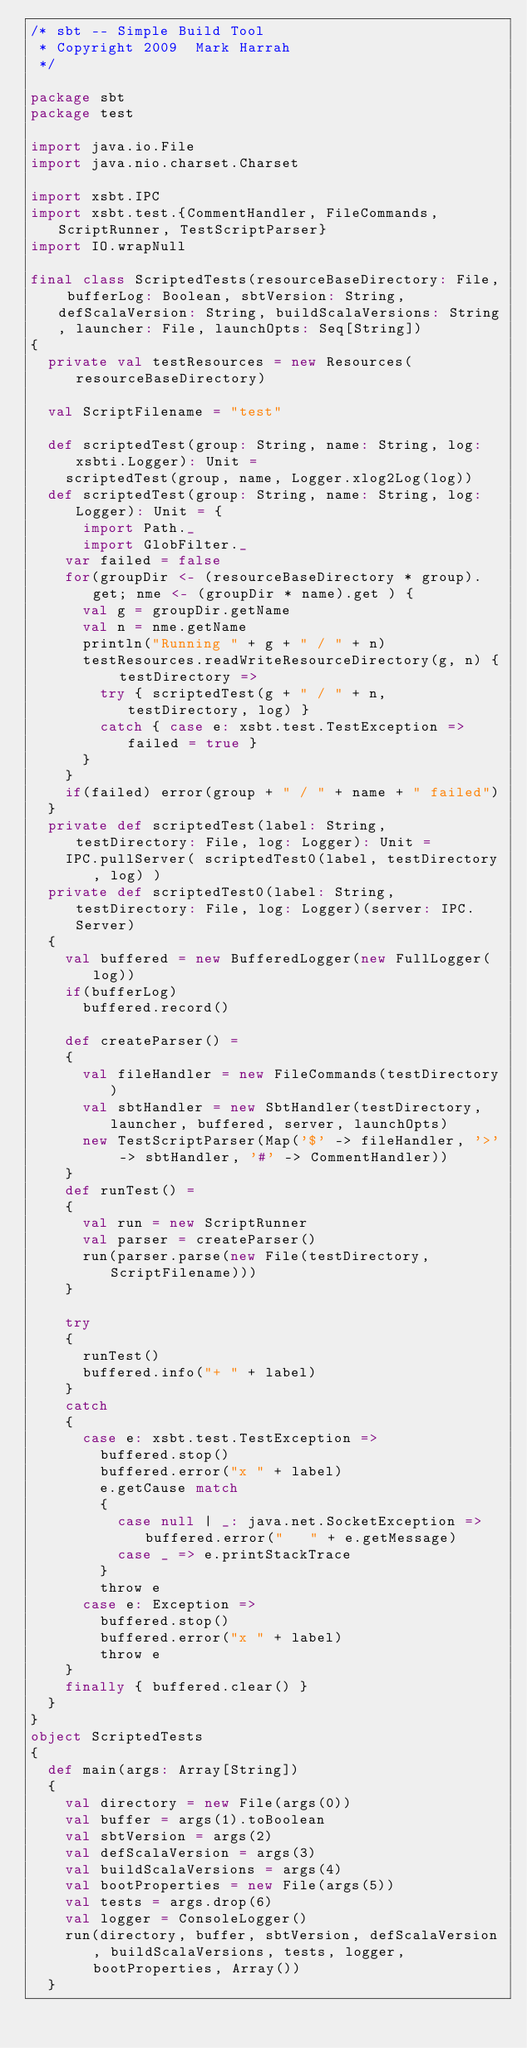Convert code to text. <code><loc_0><loc_0><loc_500><loc_500><_Scala_>/* sbt -- Simple Build Tool
 * Copyright 2009  Mark Harrah
 */

package sbt
package test

import java.io.File
import java.nio.charset.Charset

import xsbt.IPC
import xsbt.test.{CommentHandler, FileCommands, ScriptRunner, TestScriptParser}
import IO.wrapNull

final class ScriptedTests(resourceBaseDirectory: File, bufferLog: Boolean, sbtVersion: String, defScalaVersion: String, buildScalaVersions: String, launcher: File, launchOpts: Seq[String])
{
	private val testResources = new Resources(resourceBaseDirectory)
	
	val ScriptFilename = "test"
	
	def scriptedTest(group: String, name: String, log: xsbti.Logger): Unit =
		scriptedTest(group, name, Logger.xlog2Log(log))
	def scriptedTest(group: String, name: String, log: Logger): Unit = {
			import Path._
			import GlobFilter._
		var failed = false
		for(groupDir <- (resourceBaseDirectory * group).get; nme <- (groupDir * name).get ) {
			val g = groupDir.getName
			val n = nme.getName
			println("Running " + g + " / " + n)
			testResources.readWriteResourceDirectory(g, n) { testDirectory =>
				try { scriptedTest(g + " / " + n, testDirectory, log) }
				catch { case e: xsbt.test.TestException => failed = true }
			}
		}
		if(failed) error(group + " / " + name + " failed")
	}
	private def scriptedTest(label: String, testDirectory: File, log: Logger): Unit =
		IPC.pullServer( scriptedTest0(label, testDirectory, log) )
	private def scriptedTest0(label: String, testDirectory: File, log: Logger)(server: IPC.Server)
	{
		val buffered = new BufferedLogger(new FullLogger(log))
		if(bufferLog)
			buffered.record()
		
		def createParser() =
		{
			val fileHandler = new FileCommands(testDirectory)
			val sbtHandler = new SbtHandler(testDirectory, launcher, buffered, server, launchOpts)
			new TestScriptParser(Map('$' -> fileHandler, '>' -> sbtHandler, '#' -> CommentHandler))
		}
		def runTest() =
		{
			val run = new ScriptRunner
			val parser = createParser()
			run(parser.parse(new File(testDirectory, ScriptFilename)))
		}

		try
		{
			runTest()
			buffered.info("+ " + label)
		}
		catch
		{
			case e: xsbt.test.TestException =>
				buffered.stop()
				buffered.error("x " + label)
				e.getCause match
				{
					case null | _: java.net.SocketException => buffered.error("   " + e.getMessage)
					case _ => e.printStackTrace
				}
				throw e
			case e: Exception =>
				buffered.stop()
				buffered.error("x " + label)
				throw e
		}
		finally { buffered.clear() }
	}
}
object ScriptedTests
{
	def main(args: Array[String])
	{
		val directory = new File(args(0))
		val buffer = args(1).toBoolean
		val sbtVersion = args(2)
		val defScalaVersion = args(3)
		val buildScalaVersions = args(4)
		val bootProperties = new File(args(5))
		val tests = args.drop(6)
		val logger = ConsoleLogger()
		run(directory, buffer, sbtVersion, defScalaVersion, buildScalaVersions, tests, logger, bootProperties, Array())
	}</code> 